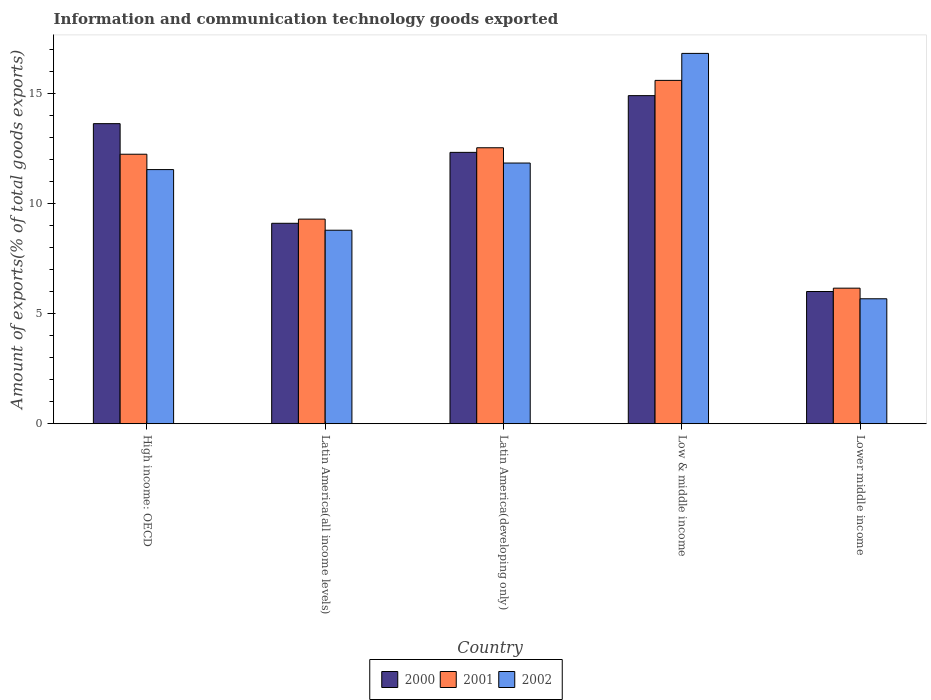How many groups of bars are there?
Give a very brief answer. 5. Are the number of bars on each tick of the X-axis equal?
Give a very brief answer. Yes. How many bars are there on the 2nd tick from the left?
Give a very brief answer. 3. How many bars are there on the 4th tick from the right?
Keep it short and to the point. 3. What is the label of the 5th group of bars from the left?
Make the answer very short. Lower middle income. In how many cases, is the number of bars for a given country not equal to the number of legend labels?
Offer a very short reply. 0. What is the amount of goods exported in 2001 in High income: OECD?
Your answer should be very brief. 12.24. Across all countries, what is the maximum amount of goods exported in 2002?
Your answer should be compact. 16.82. Across all countries, what is the minimum amount of goods exported in 2001?
Give a very brief answer. 6.16. In which country was the amount of goods exported in 2002 maximum?
Make the answer very short. Low & middle income. In which country was the amount of goods exported in 2001 minimum?
Your answer should be very brief. Lower middle income. What is the total amount of goods exported in 2000 in the graph?
Offer a very short reply. 55.98. What is the difference between the amount of goods exported in 2002 in High income: OECD and that in Low & middle income?
Offer a very short reply. -5.28. What is the difference between the amount of goods exported in 2002 in Latin America(all income levels) and the amount of goods exported in 2000 in Low & middle income?
Provide a succinct answer. -6.11. What is the average amount of goods exported in 2000 per country?
Keep it short and to the point. 11.2. What is the difference between the amount of goods exported of/in 2001 and amount of goods exported of/in 2002 in High income: OECD?
Offer a very short reply. 0.7. In how many countries, is the amount of goods exported in 2000 greater than 14 %?
Make the answer very short. 1. What is the ratio of the amount of goods exported in 2002 in Latin America(all income levels) to that in Low & middle income?
Keep it short and to the point. 0.52. What is the difference between the highest and the second highest amount of goods exported in 2002?
Provide a short and direct response. 4.98. What is the difference between the highest and the lowest amount of goods exported in 2001?
Offer a terse response. 9.44. Is the sum of the amount of goods exported in 2000 in High income: OECD and Latin America(all income levels) greater than the maximum amount of goods exported in 2002 across all countries?
Provide a succinct answer. Yes. What does the 3rd bar from the left in Low & middle income represents?
Offer a terse response. 2002. Is it the case that in every country, the sum of the amount of goods exported in 2000 and amount of goods exported in 2001 is greater than the amount of goods exported in 2002?
Give a very brief answer. Yes. How many bars are there?
Offer a very short reply. 15. How many countries are there in the graph?
Keep it short and to the point. 5. Are the values on the major ticks of Y-axis written in scientific E-notation?
Your answer should be very brief. No. Where does the legend appear in the graph?
Your answer should be very brief. Bottom center. How are the legend labels stacked?
Offer a very short reply. Horizontal. What is the title of the graph?
Ensure brevity in your answer.  Information and communication technology goods exported. What is the label or title of the Y-axis?
Your answer should be compact. Amount of exports(% of total goods exports). What is the Amount of exports(% of total goods exports) in 2000 in High income: OECD?
Keep it short and to the point. 13.63. What is the Amount of exports(% of total goods exports) of 2001 in High income: OECD?
Your answer should be compact. 12.24. What is the Amount of exports(% of total goods exports) of 2002 in High income: OECD?
Make the answer very short. 11.55. What is the Amount of exports(% of total goods exports) in 2000 in Latin America(all income levels)?
Your answer should be very brief. 9.11. What is the Amount of exports(% of total goods exports) in 2001 in Latin America(all income levels)?
Keep it short and to the point. 9.3. What is the Amount of exports(% of total goods exports) in 2002 in Latin America(all income levels)?
Your response must be concise. 8.79. What is the Amount of exports(% of total goods exports) of 2000 in Latin America(developing only)?
Offer a terse response. 12.33. What is the Amount of exports(% of total goods exports) of 2001 in Latin America(developing only)?
Give a very brief answer. 12.54. What is the Amount of exports(% of total goods exports) in 2002 in Latin America(developing only)?
Keep it short and to the point. 11.84. What is the Amount of exports(% of total goods exports) in 2000 in Low & middle income?
Provide a succinct answer. 14.91. What is the Amount of exports(% of total goods exports) in 2001 in Low & middle income?
Make the answer very short. 15.6. What is the Amount of exports(% of total goods exports) of 2002 in Low & middle income?
Offer a terse response. 16.82. What is the Amount of exports(% of total goods exports) in 2000 in Lower middle income?
Your answer should be very brief. 6.01. What is the Amount of exports(% of total goods exports) of 2001 in Lower middle income?
Provide a short and direct response. 6.16. What is the Amount of exports(% of total goods exports) in 2002 in Lower middle income?
Ensure brevity in your answer.  5.68. Across all countries, what is the maximum Amount of exports(% of total goods exports) in 2000?
Make the answer very short. 14.91. Across all countries, what is the maximum Amount of exports(% of total goods exports) in 2001?
Provide a succinct answer. 15.6. Across all countries, what is the maximum Amount of exports(% of total goods exports) in 2002?
Give a very brief answer. 16.82. Across all countries, what is the minimum Amount of exports(% of total goods exports) in 2000?
Your answer should be very brief. 6.01. Across all countries, what is the minimum Amount of exports(% of total goods exports) of 2001?
Provide a succinct answer. 6.16. Across all countries, what is the minimum Amount of exports(% of total goods exports) in 2002?
Offer a very short reply. 5.68. What is the total Amount of exports(% of total goods exports) of 2000 in the graph?
Provide a succinct answer. 55.98. What is the total Amount of exports(% of total goods exports) of 2001 in the graph?
Give a very brief answer. 55.83. What is the total Amount of exports(% of total goods exports) of 2002 in the graph?
Provide a succinct answer. 54.68. What is the difference between the Amount of exports(% of total goods exports) of 2000 in High income: OECD and that in Latin America(all income levels)?
Your answer should be compact. 4.53. What is the difference between the Amount of exports(% of total goods exports) in 2001 in High income: OECD and that in Latin America(all income levels)?
Offer a terse response. 2.95. What is the difference between the Amount of exports(% of total goods exports) of 2002 in High income: OECD and that in Latin America(all income levels)?
Provide a succinct answer. 2.75. What is the difference between the Amount of exports(% of total goods exports) of 2000 in High income: OECD and that in Latin America(developing only)?
Offer a very short reply. 1.3. What is the difference between the Amount of exports(% of total goods exports) in 2001 in High income: OECD and that in Latin America(developing only)?
Your answer should be compact. -0.29. What is the difference between the Amount of exports(% of total goods exports) of 2002 in High income: OECD and that in Latin America(developing only)?
Give a very brief answer. -0.3. What is the difference between the Amount of exports(% of total goods exports) in 2000 in High income: OECD and that in Low & middle income?
Give a very brief answer. -1.27. What is the difference between the Amount of exports(% of total goods exports) of 2001 in High income: OECD and that in Low & middle income?
Your answer should be compact. -3.36. What is the difference between the Amount of exports(% of total goods exports) in 2002 in High income: OECD and that in Low & middle income?
Provide a short and direct response. -5.28. What is the difference between the Amount of exports(% of total goods exports) of 2000 in High income: OECD and that in Lower middle income?
Your response must be concise. 7.63. What is the difference between the Amount of exports(% of total goods exports) in 2001 in High income: OECD and that in Lower middle income?
Your answer should be compact. 6.08. What is the difference between the Amount of exports(% of total goods exports) in 2002 in High income: OECD and that in Lower middle income?
Provide a succinct answer. 5.87. What is the difference between the Amount of exports(% of total goods exports) of 2000 in Latin America(all income levels) and that in Latin America(developing only)?
Your answer should be very brief. -3.22. What is the difference between the Amount of exports(% of total goods exports) of 2001 in Latin America(all income levels) and that in Latin America(developing only)?
Make the answer very short. -3.24. What is the difference between the Amount of exports(% of total goods exports) of 2002 in Latin America(all income levels) and that in Latin America(developing only)?
Your response must be concise. -3.05. What is the difference between the Amount of exports(% of total goods exports) of 2000 in Latin America(all income levels) and that in Low & middle income?
Offer a very short reply. -5.8. What is the difference between the Amount of exports(% of total goods exports) of 2001 in Latin America(all income levels) and that in Low & middle income?
Offer a terse response. -6.3. What is the difference between the Amount of exports(% of total goods exports) in 2002 in Latin America(all income levels) and that in Low & middle income?
Ensure brevity in your answer.  -8.03. What is the difference between the Amount of exports(% of total goods exports) of 2000 in Latin America(all income levels) and that in Lower middle income?
Make the answer very short. 3.1. What is the difference between the Amount of exports(% of total goods exports) of 2001 in Latin America(all income levels) and that in Lower middle income?
Provide a succinct answer. 3.14. What is the difference between the Amount of exports(% of total goods exports) of 2002 in Latin America(all income levels) and that in Lower middle income?
Make the answer very short. 3.11. What is the difference between the Amount of exports(% of total goods exports) of 2000 in Latin America(developing only) and that in Low & middle income?
Make the answer very short. -2.58. What is the difference between the Amount of exports(% of total goods exports) in 2001 in Latin America(developing only) and that in Low & middle income?
Your response must be concise. -3.06. What is the difference between the Amount of exports(% of total goods exports) in 2002 in Latin America(developing only) and that in Low & middle income?
Provide a succinct answer. -4.98. What is the difference between the Amount of exports(% of total goods exports) of 2000 in Latin America(developing only) and that in Lower middle income?
Provide a succinct answer. 6.32. What is the difference between the Amount of exports(% of total goods exports) of 2001 in Latin America(developing only) and that in Lower middle income?
Provide a short and direct response. 6.38. What is the difference between the Amount of exports(% of total goods exports) of 2002 in Latin America(developing only) and that in Lower middle income?
Provide a short and direct response. 6.17. What is the difference between the Amount of exports(% of total goods exports) of 2000 in Low & middle income and that in Lower middle income?
Provide a succinct answer. 8.9. What is the difference between the Amount of exports(% of total goods exports) of 2001 in Low & middle income and that in Lower middle income?
Offer a terse response. 9.44. What is the difference between the Amount of exports(% of total goods exports) in 2002 in Low & middle income and that in Lower middle income?
Your answer should be very brief. 11.15. What is the difference between the Amount of exports(% of total goods exports) in 2000 in High income: OECD and the Amount of exports(% of total goods exports) in 2001 in Latin America(all income levels)?
Give a very brief answer. 4.34. What is the difference between the Amount of exports(% of total goods exports) of 2000 in High income: OECD and the Amount of exports(% of total goods exports) of 2002 in Latin America(all income levels)?
Provide a succinct answer. 4.84. What is the difference between the Amount of exports(% of total goods exports) of 2001 in High income: OECD and the Amount of exports(% of total goods exports) of 2002 in Latin America(all income levels)?
Provide a succinct answer. 3.45. What is the difference between the Amount of exports(% of total goods exports) in 2000 in High income: OECD and the Amount of exports(% of total goods exports) in 2001 in Latin America(developing only)?
Provide a succinct answer. 1.1. What is the difference between the Amount of exports(% of total goods exports) in 2000 in High income: OECD and the Amount of exports(% of total goods exports) in 2002 in Latin America(developing only)?
Your response must be concise. 1.79. What is the difference between the Amount of exports(% of total goods exports) of 2001 in High income: OECD and the Amount of exports(% of total goods exports) of 2002 in Latin America(developing only)?
Your response must be concise. 0.4. What is the difference between the Amount of exports(% of total goods exports) of 2000 in High income: OECD and the Amount of exports(% of total goods exports) of 2001 in Low & middle income?
Provide a short and direct response. -1.97. What is the difference between the Amount of exports(% of total goods exports) of 2000 in High income: OECD and the Amount of exports(% of total goods exports) of 2002 in Low & middle income?
Provide a succinct answer. -3.19. What is the difference between the Amount of exports(% of total goods exports) of 2001 in High income: OECD and the Amount of exports(% of total goods exports) of 2002 in Low & middle income?
Ensure brevity in your answer.  -4.58. What is the difference between the Amount of exports(% of total goods exports) of 2000 in High income: OECD and the Amount of exports(% of total goods exports) of 2001 in Lower middle income?
Give a very brief answer. 7.47. What is the difference between the Amount of exports(% of total goods exports) in 2000 in High income: OECD and the Amount of exports(% of total goods exports) in 2002 in Lower middle income?
Ensure brevity in your answer.  7.96. What is the difference between the Amount of exports(% of total goods exports) of 2001 in High income: OECD and the Amount of exports(% of total goods exports) of 2002 in Lower middle income?
Your response must be concise. 6.57. What is the difference between the Amount of exports(% of total goods exports) of 2000 in Latin America(all income levels) and the Amount of exports(% of total goods exports) of 2001 in Latin America(developing only)?
Provide a short and direct response. -3.43. What is the difference between the Amount of exports(% of total goods exports) of 2000 in Latin America(all income levels) and the Amount of exports(% of total goods exports) of 2002 in Latin America(developing only)?
Make the answer very short. -2.74. What is the difference between the Amount of exports(% of total goods exports) in 2001 in Latin America(all income levels) and the Amount of exports(% of total goods exports) in 2002 in Latin America(developing only)?
Offer a very short reply. -2.55. What is the difference between the Amount of exports(% of total goods exports) of 2000 in Latin America(all income levels) and the Amount of exports(% of total goods exports) of 2001 in Low & middle income?
Your answer should be very brief. -6.49. What is the difference between the Amount of exports(% of total goods exports) of 2000 in Latin America(all income levels) and the Amount of exports(% of total goods exports) of 2002 in Low & middle income?
Your answer should be very brief. -7.72. What is the difference between the Amount of exports(% of total goods exports) in 2001 in Latin America(all income levels) and the Amount of exports(% of total goods exports) in 2002 in Low & middle income?
Offer a very short reply. -7.53. What is the difference between the Amount of exports(% of total goods exports) of 2000 in Latin America(all income levels) and the Amount of exports(% of total goods exports) of 2001 in Lower middle income?
Your answer should be very brief. 2.95. What is the difference between the Amount of exports(% of total goods exports) of 2000 in Latin America(all income levels) and the Amount of exports(% of total goods exports) of 2002 in Lower middle income?
Keep it short and to the point. 3.43. What is the difference between the Amount of exports(% of total goods exports) of 2001 in Latin America(all income levels) and the Amount of exports(% of total goods exports) of 2002 in Lower middle income?
Your response must be concise. 3.62. What is the difference between the Amount of exports(% of total goods exports) of 2000 in Latin America(developing only) and the Amount of exports(% of total goods exports) of 2001 in Low & middle income?
Give a very brief answer. -3.27. What is the difference between the Amount of exports(% of total goods exports) of 2000 in Latin America(developing only) and the Amount of exports(% of total goods exports) of 2002 in Low & middle income?
Offer a terse response. -4.5. What is the difference between the Amount of exports(% of total goods exports) in 2001 in Latin America(developing only) and the Amount of exports(% of total goods exports) in 2002 in Low & middle income?
Make the answer very short. -4.29. What is the difference between the Amount of exports(% of total goods exports) of 2000 in Latin America(developing only) and the Amount of exports(% of total goods exports) of 2001 in Lower middle income?
Offer a very short reply. 6.17. What is the difference between the Amount of exports(% of total goods exports) of 2000 in Latin America(developing only) and the Amount of exports(% of total goods exports) of 2002 in Lower middle income?
Your response must be concise. 6.65. What is the difference between the Amount of exports(% of total goods exports) of 2001 in Latin America(developing only) and the Amount of exports(% of total goods exports) of 2002 in Lower middle income?
Make the answer very short. 6.86. What is the difference between the Amount of exports(% of total goods exports) in 2000 in Low & middle income and the Amount of exports(% of total goods exports) in 2001 in Lower middle income?
Offer a terse response. 8.75. What is the difference between the Amount of exports(% of total goods exports) in 2000 in Low & middle income and the Amount of exports(% of total goods exports) in 2002 in Lower middle income?
Your answer should be compact. 9.23. What is the difference between the Amount of exports(% of total goods exports) in 2001 in Low & middle income and the Amount of exports(% of total goods exports) in 2002 in Lower middle income?
Ensure brevity in your answer.  9.92. What is the average Amount of exports(% of total goods exports) of 2000 per country?
Make the answer very short. 11.2. What is the average Amount of exports(% of total goods exports) of 2001 per country?
Keep it short and to the point. 11.17. What is the average Amount of exports(% of total goods exports) of 2002 per country?
Provide a short and direct response. 10.94. What is the difference between the Amount of exports(% of total goods exports) in 2000 and Amount of exports(% of total goods exports) in 2001 in High income: OECD?
Your answer should be very brief. 1.39. What is the difference between the Amount of exports(% of total goods exports) of 2000 and Amount of exports(% of total goods exports) of 2002 in High income: OECD?
Give a very brief answer. 2.09. What is the difference between the Amount of exports(% of total goods exports) of 2001 and Amount of exports(% of total goods exports) of 2002 in High income: OECD?
Your answer should be compact. 0.7. What is the difference between the Amount of exports(% of total goods exports) of 2000 and Amount of exports(% of total goods exports) of 2001 in Latin America(all income levels)?
Give a very brief answer. -0.19. What is the difference between the Amount of exports(% of total goods exports) of 2000 and Amount of exports(% of total goods exports) of 2002 in Latin America(all income levels)?
Ensure brevity in your answer.  0.32. What is the difference between the Amount of exports(% of total goods exports) of 2001 and Amount of exports(% of total goods exports) of 2002 in Latin America(all income levels)?
Your answer should be very brief. 0.5. What is the difference between the Amount of exports(% of total goods exports) of 2000 and Amount of exports(% of total goods exports) of 2001 in Latin America(developing only)?
Your response must be concise. -0.21. What is the difference between the Amount of exports(% of total goods exports) of 2000 and Amount of exports(% of total goods exports) of 2002 in Latin America(developing only)?
Provide a succinct answer. 0.49. What is the difference between the Amount of exports(% of total goods exports) of 2001 and Amount of exports(% of total goods exports) of 2002 in Latin America(developing only)?
Your answer should be compact. 0.69. What is the difference between the Amount of exports(% of total goods exports) in 2000 and Amount of exports(% of total goods exports) in 2001 in Low & middle income?
Offer a terse response. -0.69. What is the difference between the Amount of exports(% of total goods exports) in 2000 and Amount of exports(% of total goods exports) in 2002 in Low & middle income?
Provide a succinct answer. -1.92. What is the difference between the Amount of exports(% of total goods exports) of 2001 and Amount of exports(% of total goods exports) of 2002 in Low & middle income?
Keep it short and to the point. -1.23. What is the difference between the Amount of exports(% of total goods exports) in 2000 and Amount of exports(% of total goods exports) in 2001 in Lower middle income?
Offer a very short reply. -0.15. What is the difference between the Amount of exports(% of total goods exports) of 2000 and Amount of exports(% of total goods exports) of 2002 in Lower middle income?
Offer a terse response. 0.33. What is the difference between the Amount of exports(% of total goods exports) of 2001 and Amount of exports(% of total goods exports) of 2002 in Lower middle income?
Ensure brevity in your answer.  0.48. What is the ratio of the Amount of exports(% of total goods exports) of 2000 in High income: OECD to that in Latin America(all income levels)?
Give a very brief answer. 1.5. What is the ratio of the Amount of exports(% of total goods exports) in 2001 in High income: OECD to that in Latin America(all income levels)?
Ensure brevity in your answer.  1.32. What is the ratio of the Amount of exports(% of total goods exports) in 2002 in High income: OECD to that in Latin America(all income levels)?
Make the answer very short. 1.31. What is the ratio of the Amount of exports(% of total goods exports) of 2000 in High income: OECD to that in Latin America(developing only)?
Provide a succinct answer. 1.11. What is the ratio of the Amount of exports(% of total goods exports) in 2001 in High income: OECD to that in Latin America(developing only)?
Make the answer very short. 0.98. What is the ratio of the Amount of exports(% of total goods exports) of 2002 in High income: OECD to that in Latin America(developing only)?
Ensure brevity in your answer.  0.97. What is the ratio of the Amount of exports(% of total goods exports) of 2000 in High income: OECD to that in Low & middle income?
Make the answer very short. 0.91. What is the ratio of the Amount of exports(% of total goods exports) in 2001 in High income: OECD to that in Low & middle income?
Offer a terse response. 0.78. What is the ratio of the Amount of exports(% of total goods exports) in 2002 in High income: OECD to that in Low & middle income?
Your answer should be compact. 0.69. What is the ratio of the Amount of exports(% of total goods exports) of 2000 in High income: OECD to that in Lower middle income?
Your answer should be compact. 2.27. What is the ratio of the Amount of exports(% of total goods exports) of 2001 in High income: OECD to that in Lower middle income?
Provide a succinct answer. 1.99. What is the ratio of the Amount of exports(% of total goods exports) in 2002 in High income: OECD to that in Lower middle income?
Make the answer very short. 2.03. What is the ratio of the Amount of exports(% of total goods exports) of 2000 in Latin America(all income levels) to that in Latin America(developing only)?
Keep it short and to the point. 0.74. What is the ratio of the Amount of exports(% of total goods exports) in 2001 in Latin America(all income levels) to that in Latin America(developing only)?
Offer a very short reply. 0.74. What is the ratio of the Amount of exports(% of total goods exports) of 2002 in Latin America(all income levels) to that in Latin America(developing only)?
Provide a succinct answer. 0.74. What is the ratio of the Amount of exports(% of total goods exports) in 2000 in Latin America(all income levels) to that in Low & middle income?
Offer a very short reply. 0.61. What is the ratio of the Amount of exports(% of total goods exports) in 2001 in Latin America(all income levels) to that in Low & middle income?
Make the answer very short. 0.6. What is the ratio of the Amount of exports(% of total goods exports) of 2002 in Latin America(all income levels) to that in Low & middle income?
Give a very brief answer. 0.52. What is the ratio of the Amount of exports(% of total goods exports) in 2000 in Latin America(all income levels) to that in Lower middle income?
Provide a short and direct response. 1.52. What is the ratio of the Amount of exports(% of total goods exports) in 2001 in Latin America(all income levels) to that in Lower middle income?
Keep it short and to the point. 1.51. What is the ratio of the Amount of exports(% of total goods exports) of 2002 in Latin America(all income levels) to that in Lower middle income?
Ensure brevity in your answer.  1.55. What is the ratio of the Amount of exports(% of total goods exports) in 2000 in Latin America(developing only) to that in Low & middle income?
Offer a very short reply. 0.83. What is the ratio of the Amount of exports(% of total goods exports) in 2001 in Latin America(developing only) to that in Low & middle income?
Your answer should be very brief. 0.8. What is the ratio of the Amount of exports(% of total goods exports) in 2002 in Latin America(developing only) to that in Low & middle income?
Give a very brief answer. 0.7. What is the ratio of the Amount of exports(% of total goods exports) in 2000 in Latin America(developing only) to that in Lower middle income?
Your answer should be compact. 2.05. What is the ratio of the Amount of exports(% of total goods exports) in 2001 in Latin America(developing only) to that in Lower middle income?
Keep it short and to the point. 2.04. What is the ratio of the Amount of exports(% of total goods exports) of 2002 in Latin America(developing only) to that in Lower middle income?
Your answer should be compact. 2.09. What is the ratio of the Amount of exports(% of total goods exports) of 2000 in Low & middle income to that in Lower middle income?
Your response must be concise. 2.48. What is the ratio of the Amount of exports(% of total goods exports) of 2001 in Low & middle income to that in Lower middle income?
Offer a terse response. 2.53. What is the ratio of the Amount of exports(% of total goods exports) in 2002 in Low & middle income to that in Lower middle income?
Make the answer very short. 2.96. What is the difference between the highest and the second highest Amount of exports(% of total goods exports) in 2000?
Offer a very short reply. 1.27. What is the difference between the highest and the second highest Amount of exports(% of total goods exports) of 2001?
Offer a terse response. 3.06. What is the difference between the highest and the second highest Amount of exports(% of total goods exports) of 2002?
Offer a terse response. 4.98. What is the difference between the highest and the lowest Amount of exports(% of total goods exports) in 2000?
Your answer should be very brief. 8.9. What is the difference between the highest and the lowest Amount of exports(% of total goods exports) of 2001?
Provide a short and direct response. 9.44. What is the difference between the highest and the lowest Amount of exports(% of total goods exports) in 2002?
Ensure brevity in your answer.  11.15. 